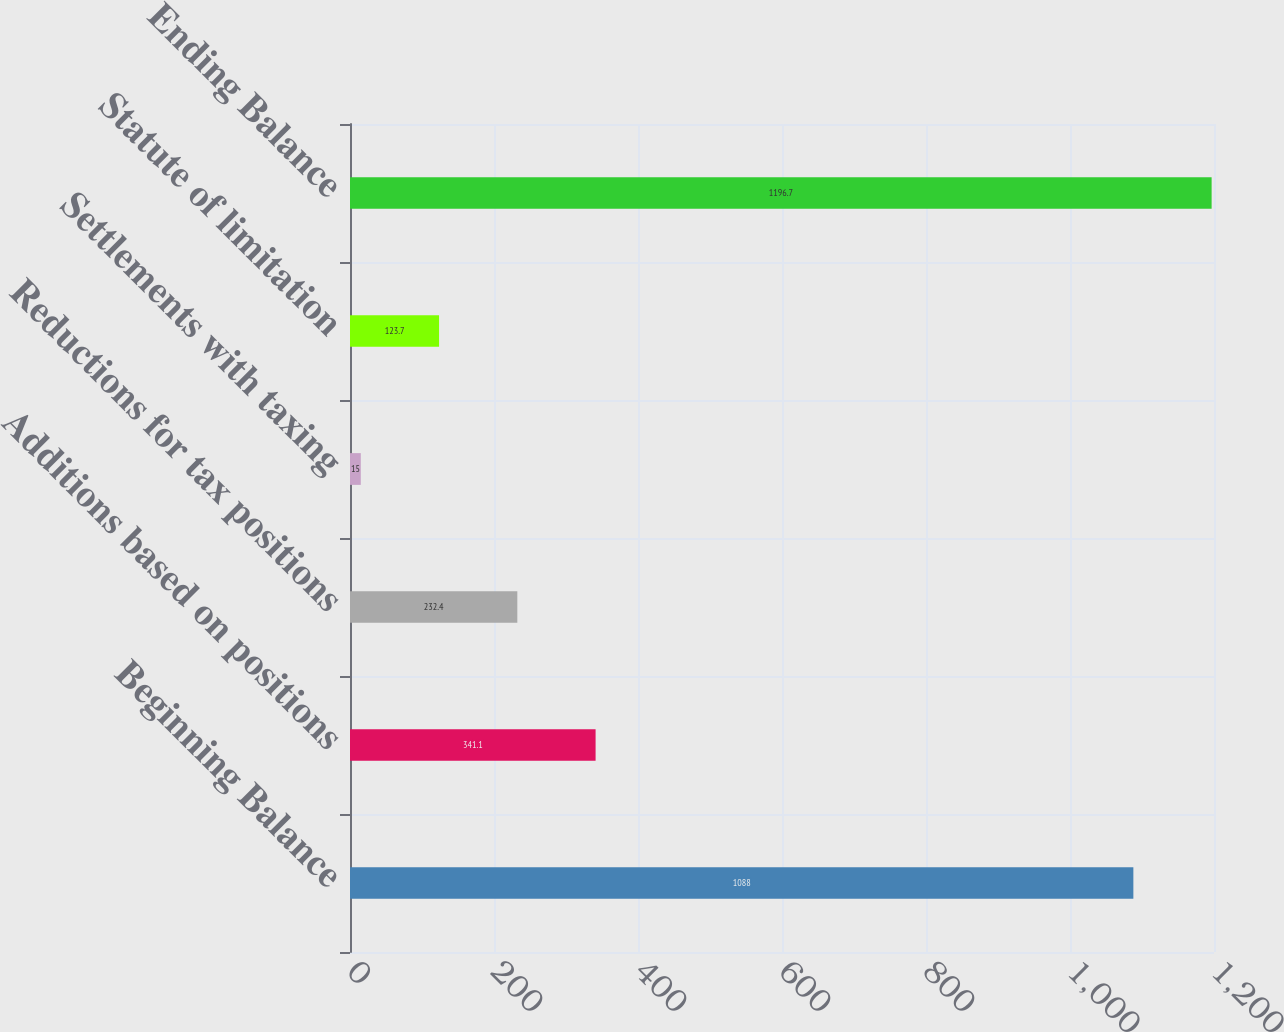Convert chart to OTSL. <chart><loc_0><loc_0><loc_500><loc_500><bar_chart><fcel>Beginning Balance<fcel>Additions based on positions<fcel>Reductions for tax positions<fcel>Settlements with taxing<fcel>Statute of limitation<fcel>Ending Balance<nl><fcel>1088<fcel>341.1<fcel>232.4<fcel>15<fcel>123.7<fcel>1196.7<nl></chart> 